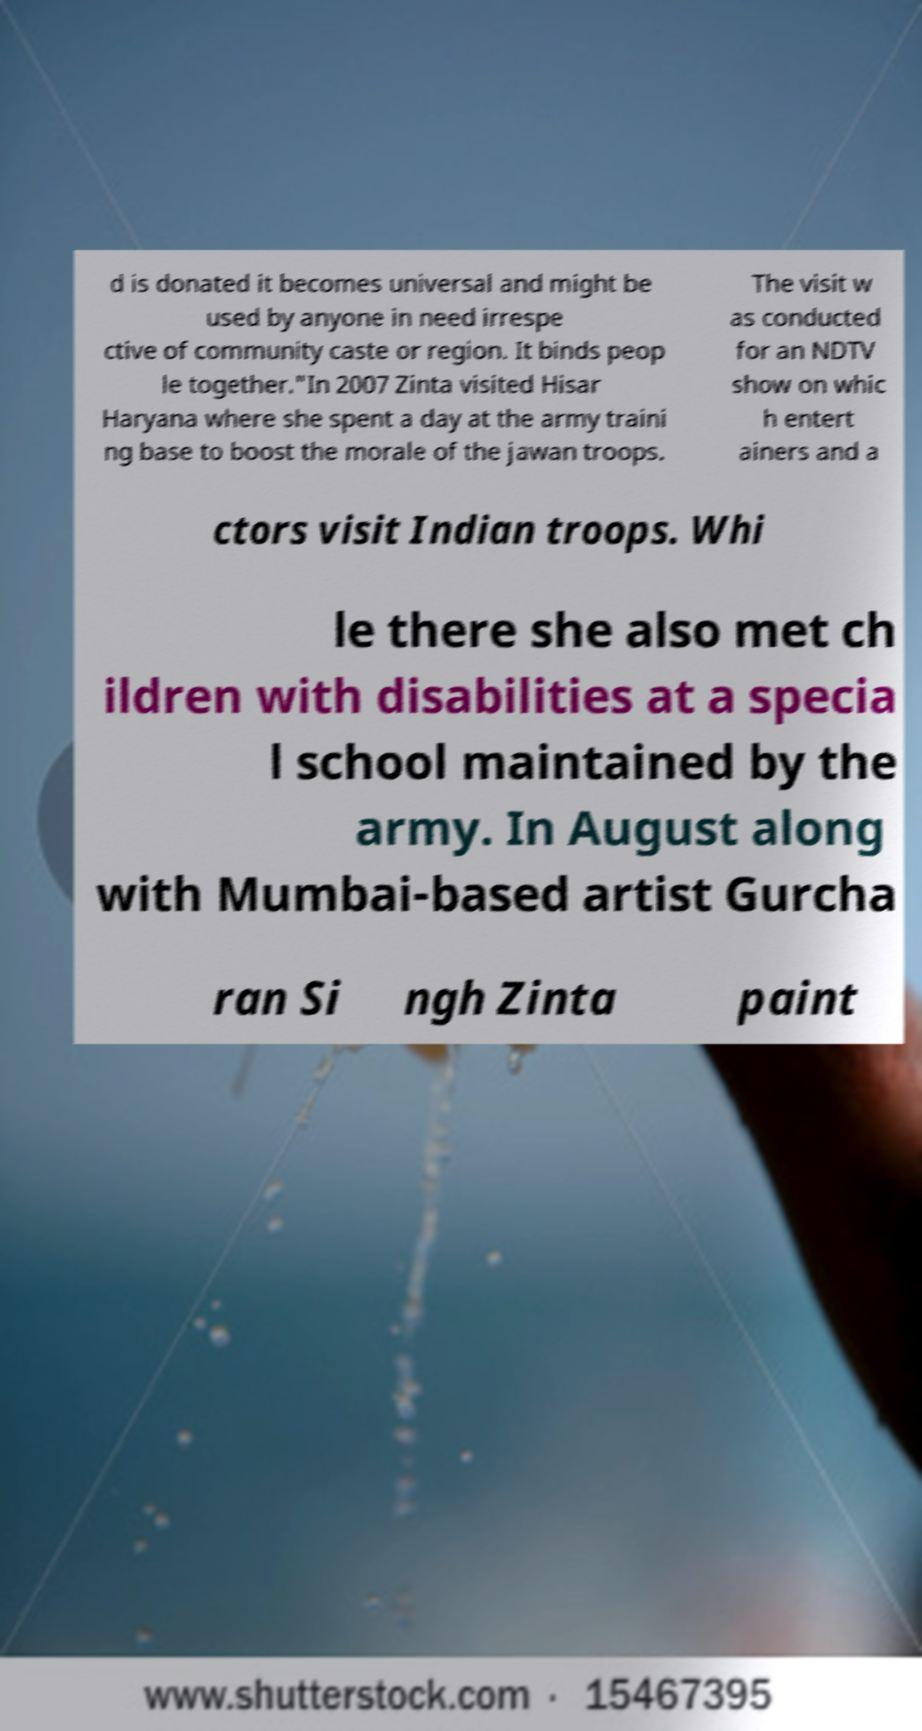What messages or text are displayed in this image? I need them in a readable, typed format. d is donated it becomes universal and might be used by anyone in need irrespe ctive of community caste or region. It binds peop le together."In 2007 Zinta visited Hisar Haryana where she spent a day at the army traini ng base to boost the morale of the jawan troops. The visit w as conducted for an NDTV show on whic h entert ainers and a ctors visit Indian troops. Whi le there she also met ch ildren with disabilities at a specia l school maintained by the army. In August along with Mumbai-based artist Gurcha ran Si ngh Zinta paint 